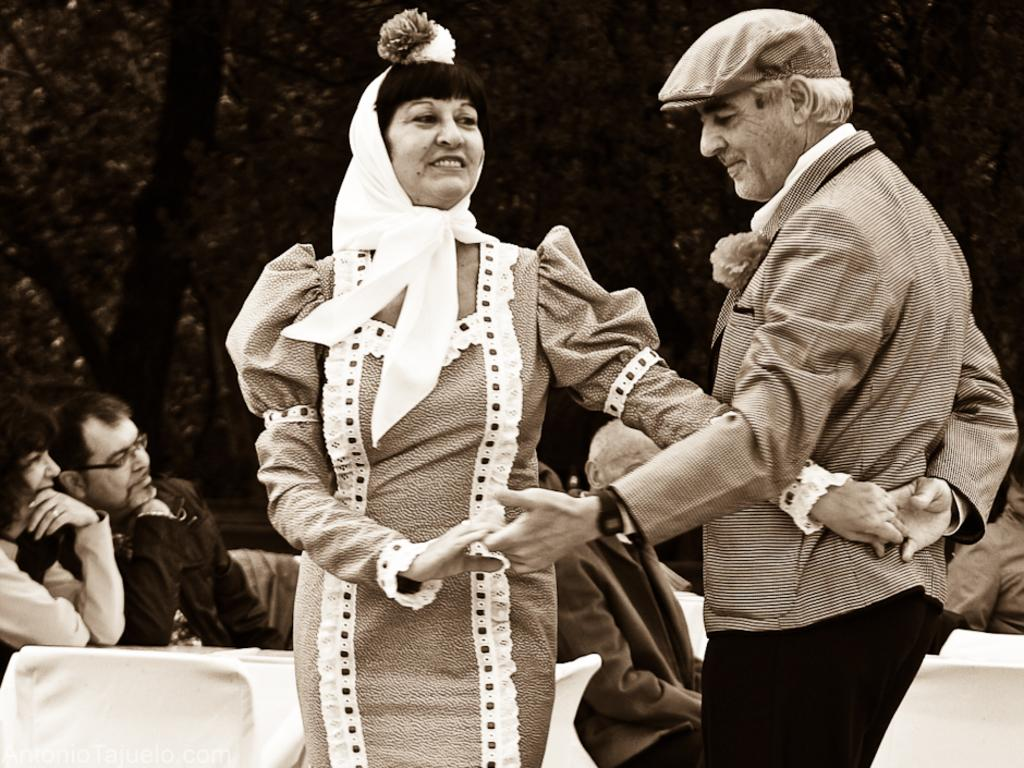How many people are in the foreground of the image? There are two people in the foreground of the image. What type of furniture is present in the image? There are chairs and tables in the image. What can be seen in the background of the image? There are trees and people in the background of the image. What statement does the maid make in the image? There is no maid present in the image, so no statement can be attributed to a maid. 